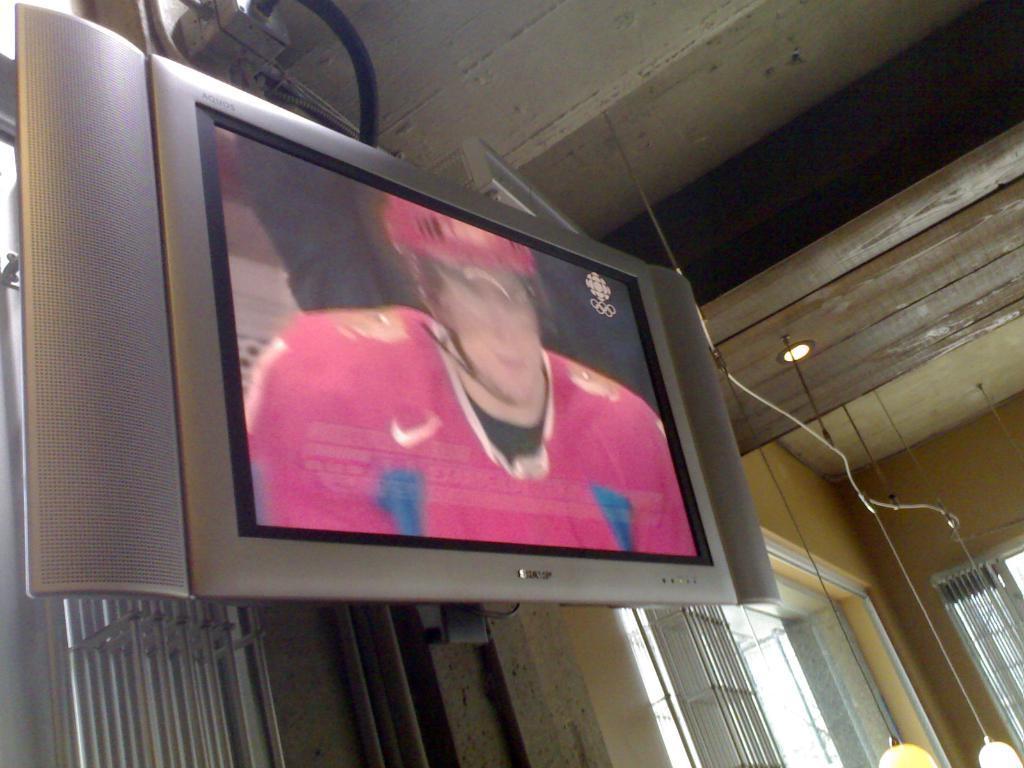Can you describe this image briefly? In this image I can see a television. In the television I can see a person and the person is wearing red and black color dress. Background I can see few windows and the wall is in yellow color and I can also see a light. 